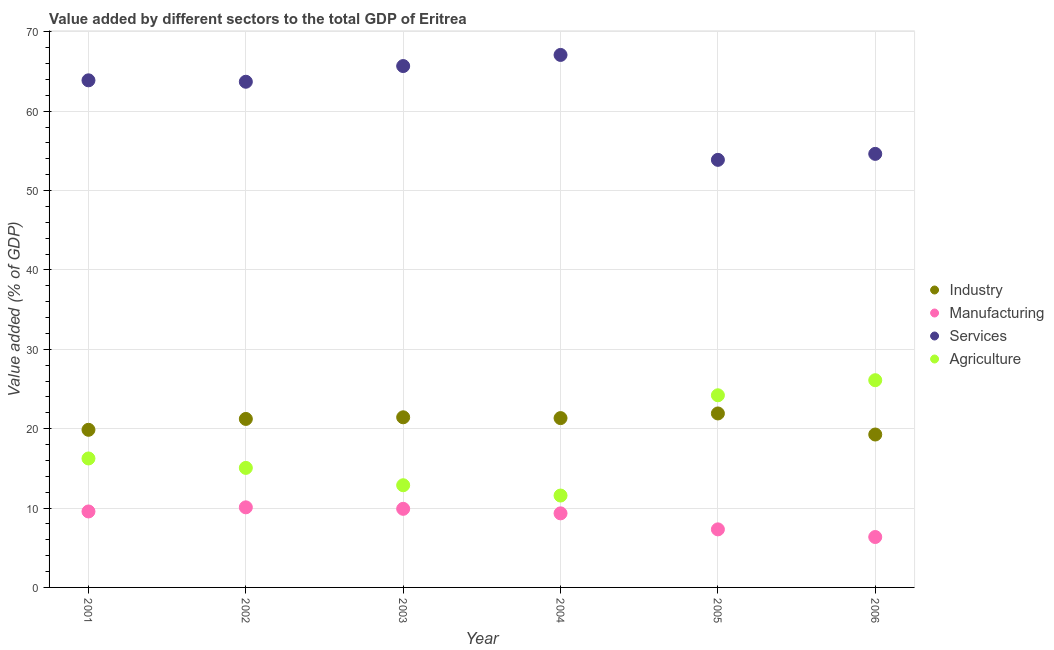How many different coloured dotlines are there?
Give a very brief answer. 4. Is the number of dotlines equal to the number of legend labels?
Ensure brevity in your answer.  Yes. What is the value added by agricultural sector in 2004?
Provide a short and direct response. 11.58. Across all years, what is the maximum value added by manufacturing sector?
Offer a terse response. 10.09. Across all years, what is the minimum value added by industrial sector?
Your answer should be compact. 19.27. In which year was the value added by services sector maximum?
Make the answer very short. 2004. In which year was the value added by manufacturing sector minimum?
Your response must be concise. 2006. What is the total value added by manufacturing sector in the graph?
Offer a terse response. 52.56. What is the difference between the value added by manufacturing sector in 2001 and that in 2002?
Your response must be concise. -0.52. What is the difference between the value added by industrial sector in 2001 and the value added by manufacturing sector in 2004?
Your response must be concise. 10.53. What is the average value added by services sector per year?
Your response must be concise. 61.48. In the year 2005, what is the difference between the value added by manufacturing sector and value added by services sector?
Your answer should be compact. -46.56. What is the ratio of the value added by industrial sector in 2003 to that in 2005?
Provide a short and direct response. 0.98. Is the value added by manufacturing sector in 2005 less than that in 2006?
Your answer should be compact. No. Is the difference between the value added by agricultural sector in 2003 and 2004 greater than the difference between the value added by services sector in 2003 and 2004?
Your answer should be compact. Yes. What is the difference between the highest and the second highest value added by manufacturing sector?
Your answer should be compact. 0.19. What is the difference between the highest and the lowest value added by agricultural sector?
Your answer should be very brief. 14.53. In how many years, is the value added by industrial sector greater than the average value added by industrial sector taken over all years?
Your answer should be compact. 4. Is the value added by manufacturing sector strictly greater than the value added by services sector over the years?
Make the answer very short. No. Is the value added by manufacturing sector strictly less than the value added by services sector over the years?
Your response must be concise. Yes. What is the difference between two consecutive major ticks on the Y-axis?
Your answer should be very brief. 10. Are the values on the major ticks of Y-axis written in scientific E-notation?
Give a very brief answer. No. Does the graph contain any zero values?
Give a very brief answer. No. Where does the legend appear in the graph?
Ensure brevity in your answer.  Center right. How many legend labels are there?
Provide a succinct answer. 4. How are the legend labels stacked?
Your answer should be very brief. Vertical. What is the title of the graph?
Your response must be concise. Value added by different sectors to the total GDP of Eritrea. What is the label or title of the Y-axis?
Provide a succinct answer. Value added (% of GDP). What is the Value added (% of GDP) in Industry in 2001?
Give a very brief answer. 19.86. What is the Value added (% of GDP) of Manufacturing in 2001?
Your answer should be compact. 9.57. What is the Value added (% of GDP) in Services in 2001?
Ensure brevity in your answer.  63.89. What is the Value added (% of GDP) of Agriculture in 2001?
Your response must be concise. 16.25. What is the Value added (% of GDP) in Industry in 2002?
Your answer should be very brief. 21.23. What is the Value added (% of GDP) of Manufacturing in 2002?
Your answer should be compact. 10.09. What is the Value added (% of GDP) in Services in 2002?
Keep it short and to the point. 63.71. What is the Value added (% of GDP) in Agriculture in 2002?
Ensure brevity in your answer.  15.06. What is the Value added (% of GDP) of Industry in 2003?
Provide a succinct answer. 21.44. What is the Value added (% of GDP) of Manufacturing in 2003?
Offer a terse response. 9.9. What is the Value added (% of GDP) in Services in 2003?
Keep it short and to the point. 65.69. What is the Value added (% of GDP) of Agriculture in 2003?
Offer a very short reply. 12.87. What is the Value added (% of GDP) of Industry in 2004?
Ensure brevity in your answer.  21.33. What is the Value added (% of GDP) in Manufacturing in 2004?
Offer a very short reply. 9.33. What is the Value added (% of GDP) in Services in 2004?
Your answer should be compact. 67.09. What is the Value added (% of GDP) of Agriculture in 2004?
Ensure brevity in your answer.  11.58. What is the Value added (% of GDP) of Industry in 2005?
Your response must be concise. 21.92. What is the Value added (% of GDP) in Manufacturing in 2005?
Your answer should be very brief. 7.31. What is the Value added (% of GDP) of Services in 2005?
Your answer should be very brief. 53.87. What is the Value added (% of GDP) of Agriculture in 2005?
Offer a very short reply. 24.21. What is the Value added (% of GDP) of Industry in 2006?
Your answer should be very brief. 19.27. What is the Value added (% of GDP) in Manufacturing in 2006?
Make the answer very short. 6.35. What is the Value added (% of GDP) in Services in 2006?
Provide a succinct answer. 54.63. What is the Value added (% of GDP) of Agriculture in 2006?
Your answer should be very brief. 26.11. Across all years, what is the maximum Value added (% of GDP) of Industry?
Keep it short and to the point. 21.92. Across all years, what is the maximum Value added (% of GDP) in Manufacturing?
Your answer should be compact. 10.09. Across all years, what is the maximum Value added (% of GDP) of Services?
Keep it short and to the point. 67.09. Across all years, what is the maximum Value added (% of GDP) of Agriculture?
Your response must be concise. 26.11. Across all years, what is the minimum Value added (% of GDP) of Industry?
Your response must be concise. 19.27. Across all years, what is the minimum Value added (% of GDP) in Manufacturing?
Your answer should be compact. 6.35. Across all years, what is the minimum Value added (% of GDP) of Services?
Make the answer very short. 53.87. Across all years, what is the minimum Value added (% of GDP) in Agriculture?
Provide a short and direct response. 11.58. What is the total Value added (% of GDP) in Industry in the graph?
Provide a short and direct response. 125.04. What is the total Value added (% of GDP) of Manufacturing in the graph?
Offer a very short reply. 52.56. What is the total Value added (% of GDP) in Services in the graph?
Provide a short and direct response. 368.88. What is the total Value added (% of GDP) in Agriculture in the graph?
Provide a succinct answer. 106.08. What is the difference between the Value added (% of GDP) in Industry in 2001 and that in 2002?
Offer a very short reply. -1.37. What is the difference between the Value added (% of GDP) of Manufacturing in 2001 and that in 2002?
Offer a very short reply. -0.52. What is the difference between the Value added (% of GDP) in Services in 2001 and that in 2002?
Provide a succinct answer. 0.18. What is the difference between the Value added (% of GDP) in Agriculture in 2001 and that in 2002?
Provide a succinct answer. 1.19. What is the difference between the Value added (% of GDP) in Industry in 2001 and that in 2003?
Provide a succinct answer. -1.58. What is the difference between the Value added (% of GDP) of Manufacturing in 2001 and that in 2003?
Offer a terse response. -0.33. What is the difference between the Value added (% of GDP) of Services in 2001 and that in 2003?
Your answer should be very brief. -1.8. What is the difference between the Value added (% of GDP) in Agriculture in 2001 and that in 2003?
Ensure brevity in your answer.  3.37. What is the difference between the Value added (% of GDP) of Industry in 2001 and that in 2004?
Provide a succinct answer. -1.47. What is the difference between the Value added (% of GDP) in Manufacturing in 2001 and that in 2004?
Your answer should be compact. 0.24. What is the difference between the Value added (% of GDP) in Services in 2001 and that in 2004?
Provide a succinct answer. -3.2. What is the difference between the Value added (% of GDP) in Agriculture in 2001 and that in 2004?
Make the answer very short. 4.67. What is the difference between the Value added (% of GDP) in Industry in 2001 and that in 2005?
Your answer should be very brief. -2.06. What is the difference between the Value added (% of GDP) in Manufacturing in 2001 and that in 2005?
Make the answer very short. 2.26. What is the difference between the Value added (% of GDP) of Services in 2001 and that in 2005?
Your answer should be very brief. 10.02. What is the difference between the Value added (% of GDP) of Agriculture in 2001 and that in 2005?
Provide a short and direct response. -7.96. What is the difference between the Value added (% of GDP) of Industry in 2001 and that in 2006?
Your answer should be very brief. 0.59. What is the difference between the Value added (% of GDP) of Manufacturing in 2001 and that in 2006?
Make the answer very short. 3.22. What is the difference between the Value added (% of GDP) of Services in 2001 and that in 2006?
Provide a succinct answer. 9.27. What is the difference between the Value added (% of GDP) in Agriculture in 2001 and that in 2006?
Provide a succinct answer. -9.86. What is the difference between the Value added (% of GDP) in Industry in 2002 and that in 2003?
Offer a terse response. -0.21. What is the difference between the Value added (% of GDP) in Manufacturing in 2002 and that in 2003?
Your answer should be compact. 0.19. What is the difference between the Value added (% of GDP) of Services in 2002 and that in 2003?
Make the answer very short. -1.98. What is the difference between the Value added (% of GDP) of Agriculture in 2002 and that in 2003?
Your response must be concise. 2.19. What is the difference between the Value added (% of GDP) of Industry in 2002 and that in 2004?
Provide a short and direct response. -0.1. What is the difference between the Value added (% of GDP) of Manufacturing in 2002 and that in 2004?
Give a very brief answer. 0.76. What is the difference between the Value added (% of GDP) in Services in 2002 and that in 2004?
Provide a short and direct response. -3.38. What is the difference between the Value added (% of GDP) in Agriculture in 2002 and that in 2004?
Your answer should be very brief. 3.48. What is the difference between the Value added (% of GDP) of Industry in 2002 and that in 2005?
Offer a very short reply. -0.69. What is the difference between the Value added (% of GDP) of Manufacturing in 2002 and that in 2005?
Provide a short and direct response. 2.78. What is the difference between the Value added (% of GDP) of Services in 2002 and that in 2005?
Your answer should be compact. 9.84. What is the difference between the Value added (% of GDP) in Agriculture in 2002 and that in 2005?
Give a very brief answer. -9.15. What is the difference between the Value added (% of GDP) in Industry in 2002 and that in 2006?
Provide a succinct answer. 1.96. What is the difference between the Value added (% of GDP) of Manufacturing in 2002 and that in 2006?
Your answer should be very brief. 3.74. What is the difference between the Value added (% of GDP) in Services in 2002 and that in 2006?
Your answer should be compact. 9.09. What is the difference between the Value added (% of GDP) in Agriculture in 2002 and that in 2006?
Keep it short and to the point. -11.05. What is the difference between the Value added (% of GDP) of Industry in 2003 and that in 2004?
Keep it short and to the point. 0.1. What is the difference between the Value added (% of GDP) in Manufacturing in 2003 and that in 2004?
Your answer should be compact. 0.57. What is the difference between the Value added (% of GDP) in Services in 2003 and that in 2004?
Keep it short and to the point. -1.4. What is the difference between the Value added (% of GDP) in Agriculture in 2003 and that in 2004?
Provide a short and direct response. 1.3. What is the difference between the Value added (% of GDP) of Industry in 2003 and that in 2005?
Make the answer very short. -0.48. What is the difference between the Value added (% of GDP) in Manufacturing in 2003 and that in 2005?
Your answer should be compact. 2.59. What is the difference between the Value added (% of GDP) of Services in 2003 and that in 2005?
Make the answer very short. 11.82. What is the difference between the Value added (% of GDP) of Agriculture in 2003 and that in 2005?
Offer a very short reply. -11.33. What is the difference between the Value added (% of GDP) of Industry in 2003 and that in 2006?
Offer a very short reply. 2.17. What is the difference between the Value added (% of GDP) of Manufacturing in 2003 and that in 2006?
Offer a terse response. 3.55. What is the difference between the Value added (% of GDP) in Services in 2003 and that in 2006?
Your response must be concise. 11.06. What is the difference between the Value added (% of GDP) in Agriculture in 2003 and that in 2006?
Offer a terse response. -13.23. What is the difference between the Value added (% of GDP) of Industry in 2004 and that in 2005?
Your answer should be very brief. -0.59. What is the difference between the Value added (% of GDP) of Manufacturing in 2004 and that in 2005?
Ensure brevity in your answer.  2.02. What is the difference between the Value added (% of GDP) in Services in 2004 and that in 2005?
Offer a very short reply. 13.22. What is the difference between the Value added (% of GDP) of Agriculture in 2004 and that in 2005?
Your answer should be very brief. -12.63. What is the difference between the Value added (% of GDP) in Industry in 2004 and that in 2006?
Offer a terse response. 2.07. What is the difference between the Value added (% of GDP) in Manufacturing in 2004 and that in 2006?
Your answer should be very brief. 2.98. What is the difference between the Value added (% of GDP) in Services in 2004 and that in 2006?
Your response must be concise. 12.47. What is the difference between the Value added (% of GDP) of Agriculture in 2004 and that in 2006?
Your answer should be very brief. -14.53. What is the difference between the Value added (% of GDP) of Industry in 2005 and that in 2006?
Offer a terse response. 2.65. What is the difference between the Value added (% of GDP) in Manufacturing in 2005 and that in 2006?
Provide a short and direct response. 0.96. What is the difference between the Value added (% of GDP) in Services in 2005 and that in 2006?
Ensure brevity in your answer.  -0.75. What is the difference between the Value added (% of GDP) of Agriculture in 2005 and that in 2006?
Ensure brevity in your answer.  -1.9. What is the difference between the Value added (% of GDP) in Industry in 2001 and the Value added (% of GDP) in Manufacturing in 2002?
Give a very brief answer. 9.77. What is the difference between the Value added (% of GDP) of Industry in 2001 and the Value added (% of GDP) of Services in 2002?
Your response must be concise. -43.85. What is the difference between the Value added (% of GDP) of Industry in 2001 and the Value added (% of GDP) of Agriculture in 2002?
Offer a terse response. 4.8. What is the difference between the Value added (% of GDP) in Manufacturing in 2001 and the Value added (% of GDP) in Services in 2002?
Give a very brief answer. -54.14. What is the difference between the Value added (% of GDP) in Manufacturing in 2001 and the Value added (% of GDP) in Agriculture in 2002?
Your answer should be compact. -5.49. What is the difference between the Value added (% of GDP) of Services in 2001 and the Value added (% of GDP) of Agriculture in 2002?
Your answer should be compact. 48.83. What is the difference between the Value added (% of GDP) of Industry in 2001 and the Value added (% of GDP) of Manufacturing in 2003?
Ensure brevity in your answer.  9.96. What is the difference between the Value added (% of GDP) of Industry in 2001 and the Value added (% of GDP) of Services in 2003?
Your response must be concise. -45.83. What is the difference between the Value added (% of GDP) in Industry in 2001 and the Value added (% of GDP) in Agriculture in 2003?
Offer a very short reply. 6.98. What is the difference between the Value added (% of GDP) in Manufacturing in 2001 and the Value added (% of GDP) in Services in 2003?
Provide a succinct answer. -56.12. What is the difference between the Value added (% of GDP) in Manufacturing in 2001 and the Value added (% of GDP) in Agriculture in 2003?
Keep it short and to the point. -3.3. What is the difference between the Value added (% of GDP) in Services in 2001 and the Value added (% of GDP) in Agriculture in 2003?
Offer a very short reply. 51.02. What is the difference between the Value added (% of GDP) in Industry in 2001 and the Value added (% of GDP) in Manufacturing in 2004?
Your answer should be compact. 10.53. What is the difference between the Value added (% of GDP) of Industry in 2001 and the Value added (% of GDP) of Services in 2004?
Provide a succinct answer. -47.23. What is the difference between the Value added (% of GDP) of Industry in 2001 and the Value added (% of GDP) of Agriculture in 2004?
Your answer should be very brief. 8.28. What is the difference between the Value added (% of GDP) in Manufacturing in 2001 and the Value added (% of GDP) in Services in 2004?
Offer a terse response. -57.52. What is the difference between the Value added (% of GDP) in Manufacturing in 2001 and the Value added (% of GDP) in Agriculture in 2004?
Give a very brief answer. -2. What is the difference between the Value added (% of GDP) of Services in 2001 and the Value added (% of GDP) of Agriculture in 2004?
Offer a terse response. 52.32. What is the difference between the Value added (% of GDP) in Industry in 2001 and the Value added (% of GDP) in Manufacturing in 2005?
Keep it short and to the point. 12.55. What is the difference between the Value added (% of GDP) of Industry in 2001 and the Value added (% of GDP) of Services in 2005?
Provide a short and direct response. -34.01. What is the difference between the Value added (% of GDP) in Industry in 2001 and the Value added (% of GDP) in Agriculture in 2005?
Offer a very short reply. -4.35. What is the difference between the Value added (% of GDP) in Manufacturing in 2001 and the Value added (% of GDP) in Services in 2005?
Your response must be concise. -44.3. What is the difference between the Value added (% of GDP) in Manufacturing in 2001 and the Value added (% of GDP) in Agriculture in 2005?
Provide a short and direct response. -14.64. What is the difference between the Value added (% of GDP) of Services in 2001 and the Value added (% of GDP) of Agriculture in 2005?
Keep it short and to the point. 39.68. What is the difference between the Value added (% of GDP) in Industry in 2001 and the Value added (% of GDP) in Manufacturing in 2006?
Provide a short and direct response. 13.51. What is the difference between the Value added (% of GDP) in Industry in 2001 and the Value added (% of GDP) in Services in 2006?
Offer a very short reply. -34.77. What is the difference between the Value added (% of GDP) in Industry in 2001 and the Value added (% of GDP) in Agriculture in 2006?
Provide a short and direct response. -6.25. What is the difference between the Value added (% of GDP) in Manufacturing in 2001 and the Value added (% of GDP) in Services in 2006?
Provide a short and direct response. -45.05. What is the difference between the Value added (% of GDP) in Manufacturing in 2001 and the Value added (% of GDP) in Agriculture in 2006?
Your answer should be compact. -16.54. What is the difference between the Value added (% of GDP) in Services in 2001 and the Value added (% of GDP) in Agriculture in 2006?
Offer a very short reply. 37.78. What is the difference between the Value added (% of GDP) in Industry in 2002 and the Value added (% of GDP) in Manufacturing in 2003?
Offer a terse response. 11.33. What is the difference between the Value added (% of GDP) in Industry in 2002 and the Value added (% of GDP) in Services in 2003?
Your answer should be compact. -44.46. What is the difference between the Value added (% of GDP) in Industry in 2002 and the Value added (% of GDP) in Agriculture in 2003?
Make the answer very short. 8.35. What is the difference between the Value added (% of GDP) in Manufacturing in 2002 and the Value added (% of GDP) in Services in 2003?
Your answer should be very brief. -55.6. What is the difference between the Value added (% of GDP) in Manufacturing in 2002 and the Value added (% of GDP) in Agriculture in 2003?
Provide a succinct answer. -2.78. What is the difference between the Value added (% of GDP) of Services in 2002 and the Value added (% of GDP) of Agriculture in 2003?
Your response must be concise. 50.84. What is the difference between the Value added (% of GDP) of Industry in 2002 and the Value added (% of GDP) of Manufacturing in 2004?
Keep it short and to the point. 11.9. What is the difference between the Value added (% of GDP) in Industry in 2002 and the Value added (% of GDP) in Services in 2004?
Ensure brevity in your answer.  -45.86. What is the difference between the Value added (% of GDP) in Industry in 2002 and the Value added (% of GDP) in Agriculture in 2004?
Your answer should be compact. 9.65. What is the difference between the Value added (% of GDP) of Manufacturing in 2002 and the Value added (% of GDP) of Services in 2004?
Provide a short and direct response. -57. What is the difference between the Value added (% of GDP) of Manufacturing in 2002 and the Value added (% of GDP) of Agriculture in 2004?
Give a very brief answer. -1.49. What is the difference between the Value added (% of GDP) of Services in 2002 and the Value added (% of GDP) of Agriculture in 2004?
Make the answer very short. 52.14. What is the difference between the Value added (% of GDP) in Industry in 2002 and the Value added (% of GDP) in Manufacturing in 2005?
Make the answer very short. 13.91. What is the difference between the Value added (% of GDP) in Industry in 2002 and the Value added (% of GDP) in Services in 2005?
Your answer should be compact. -32.64. What is the difference between the Value added (% of GDP) in Industry in 2002 and the Value added (% of GDP) in Agriculture in 2005?
Keep it short and to the point. -2.98. What is the difference between the Value added (% of GDP) in Manufacturing in 2002 and the Value added (% of GDP) in Services in 2005?
Your answer should be very brief. -43.78. What is the difference between the Value added (% of GDP) of Manufacturing in 2002 and the Value added (% of GDP) of Agriculture in 2005?
Your answer should be compact. -14.12. What is the difference between the Value added (% of GDP) in Services in 2002 and the Value added (% of GDP) in Agriculture in 2005?
Offer a very short reply. 39.5. What is the difference between the Value added (% of GDP) in Industry in 2002 and the Value added (% of GDP) in Manufacturing in 2006?
Offer a terse response. 14.88. What is the difference between the Value added (% of GDP) in Industry in 2002 and the Value added (% of GDP) in Services in 2006?
Give a very brief answer. -33.4. What is the difference between the Value added (% of GDP) of Industry in 2002 and the Value added (% of GDP) of Agriculture in 2006?
Make the answer very short. -4.88. What is the difference between the Value added (% of GDP) of Manufacturing in 2002 and the Value added (% of GDP) of Services in 2006?
Your response must be concise. -44.53. What is the difference between the Value added (% of GDP) of Manufacturing in 2002 and the Value added (% of GDP) of Agriculture in 2006?
Your response must be concise. -16.02. What is the difference between the Value added (% of GDP) in Services in 2002 and the Value added (% of GDP) in Agriculture in 2006?
Provide a succinct answer. 37.6. What is the difference between the Value added (% of GDP) of Industry in 2003 and the Value added (% of GDP) of Manufacturing in 2004?
Give a very brief answer. 12.1. What is the difference between the Value added (% of GDP) in Industry in 2003 and the Value added (% of GDP) in Services in 2004?
Offer a very short reply. -45.66. What is the difference between the Value added (% of GDP) of Industry in 2003 and the Value added (% of GDP) of Agriculture in 2004?
Your answer should be very brief. 9.86. What is the difference between the Value added (% of GDP) in Manufacturing in 2003 and the Value added (% of GDP) in Services in 2004?
Provide a succinct answer. -57.19. What is the difference between the Value added (% of GDP) of Manufacturing in 2003 and the Value added (% of GDP) of Agriculture in 2004?
Keep it short and to the point. -1.67. What is the difference between the Value added (% of GDP) in Services in 2003 and the Value added (% of GDP) in Agriculture in 2004?
Give a very brief answer. 54.11. What is the difference between the Value added (% of GDP) in Industry in 2003 and the Value added (% of GDP) in Manufacturing in 2005?
Ensure brevity in your answer.  14.12. What is the difference between the Value added (% of GDP) of Industry in 2003 and the Value added (% of GDP) of Services in 2005?
Your answer should be very brief. -32.44. What is the difference between the Value added (% of GDP) in Industry in 2003 and the Value added (% of GDP) in Agriculture in 2005?
Your response must be concise. -2.77. What is the difference between the Value added (% of GDP) in Manufacturing in 2003 and the Value added (% of GDP) in Services in 2005?
Provide a succinct answer. -43.97. What is the difference between the Value added (% of GDP) in Manufacturing in 2003 and the Value added (% of GDP) in Agriculture in 2005?
Provide a short and direct response. -14.31. What is the difference between the Value added (% of GDP) in Services in 2003 and the Value added (% of GDP) in Agriculture in 2005?
Provide a succinct answer. 41.48. What is the difference between the Value added (% of GDP) of Industry in 2003 and the Value added (% of GDP) of Manufacturing in 2006?
Ensure brevity in your answer.  15.08. What is the difference between the Value added (% of GDP) in Industry in 2003 and the Value added (% of GDP) in Services in 2006?
Your response must be concise. -33.19. What is the difference between the Value added (% of GDP) in Industry in 2003 and the Value added (% of GDP) in Agriculture in 2006?
Your response must be concise. -4.67. What is the difference between the Value added (% of GDP) of Manufacturing in 2003 and the Value added (% of GDP) of Services in 2006?
Your response must be concise. -44.72. What is the difference between the Value added (% of GDP) in Manufacturing in 2003 and the Value added (% of GDP) in Agriculture in 2006?
Offer a very short reply. -16.21. What is the difference between the Value added (% of GDP) of Services in 2003 and the Value added (% of GDP) of Agriculture in 2006?
Your answer should be compact. 39.58. What is the difference between the Value added (% of GDP) of Industry in 2004 and the Value added (% of GDP) of Manufacturing in 2005?
Offer a very short reply. 14.02. What is the difference between the Value added (% of GDP) of Industry in 2004 and the Value added (% of GDP) of Services in 2005?
Make the answer very short. -32.54. What is the difference between the Value added (% of GDP) of Industry in 2004 and the Value added (% of GDP) of Agriculture in 2005?
Your answer should be compact. -2.88. What is the difference between the Value added (% of GDP) in Manufacturing in 2004 and the Value added (% of GDP) in Services in 2005?
Ensure brevity in your answer.  -44.54. What is the difference between the Value added (% of GDP) of Manufacturing in 2004 and the Value added (% of GDP) of Agriculture in 2005?
Make the answer very short. -14.88. What is the difference between the Value added (% of GDP) in Services in 2004 and the Value added (% of GDP) in Agriculture in 2005?
Offer a very short reply. 42.88. What is the difference between the Value added (% of GDP) in Industry in 2004 and the Value added (% of GDP) in Manufacturing in 2006?
Your answer should be compact. 14.98. What is the difference between the Value added (% of GDP) of Industry in 2004 and the Value added (% of GDP) of Services in 2006?
Your answer should be very brief. -33.29. What is the difference between the Value added (% of GDP) of Industry in 2004 and the Value added (% of GDP) of Agriculture in 2006?
Ensure brevity in your answer.  -4.78. What is the difference between the Value added (% of GDP) of Manufacturing in 2004 and the Value added (% of GDP) of Services in 2006?
Your answer should be very brief. -45.29. What is the difference between the Value added (% of GDP) of Manufacturing in 2004 and the Value added (% of GDP) of Agriculture in 2006?
Provide a short and direct response. -16.78. What is the difference between the Value added (% of GDP) in Services in 2004 and the Value added (% of GDP) in Agriculture in 2006?
Provide a succinct answer. 40.98. What is the difference between the Value added (% of GDP) of Industry in 2005 and the Value added (% of GDP) of Manufacturing in 2006?
Offer a terse response. 15.57. What is the difference between the Value added (% of GDP) of Industry in 2005 and the Value added (% of GDP) of Services in 2006?
Give a very brief answer. -32.71. What is the difference between the Value added (% of GDP) of Industry in 2005 and the Value added (% of GDP) of Agriculture in 2006?
Your answer should be compact. -4.19. What is the difference between the Value added (% of GDP) of Manufacturing in 2005 and the Value added (% of GDP) of Services in 2006?
Your answer should be compact. -47.31. What is the difference between the Value added (% of GDP) of Manufacturing in 2005 and the Value added (% of GDP) of Agriculture in 2006?
Make the answer very short. -18.79. What is the difference between the Value added (% of GDP) in Services in 2005 and the Value added (% of GDP) in Agriculture in 2006?
Your response must be concise. 27.76. What is the average Value added (% of GDP) of Industry per year?
Offer a terse response. 20.84. What is the average Value added (% of GDP) of Manufacturing per year?
Keep it short and to the point. 8.76. What is the average Value added (% of GDP) of Services per year?
Offer a terse response. 61.48. What is the average Value added (% of GDP) of Agriculture per year?
Offer a very short reply. 17.68. In the year 2001, what is the difference between the Value added (% of GDP) of Industry and Value added (% of GDP) of Manufacturing?
Provide a short and direct response. 10.29. In the year 2001, what is the difference between the Value added (% of GDP) of Industry and Value added (% of GDP) of Services?
Your answer should be compact. -44.03. In the year 2001, what is the difference between the Value added (% of GDP) of Industry and Value added (% of GDP) of Agriculture?
Make the answer very short. 3.61. In the year 2001, what is the difference between the Value added (% of GDP) of Manufacturing and Value added (% of GDP) of Services?
Your answer should be compact. -54.32. In the year 2001, what is the difference between the Value added (% of GDP) in Manufacturing and Value added (% of GDP) in Agriculture?
Your answer should be very brief. -6.68. In the year 2001, what is the difference between the Value added (% of GDP) of Services and Value added (% of GDP) of Agriculture?
Make the answer very short. 47.64. In the year 2002, what is the difference between the Value added (% of GDP) of Industry and Value added (% of GDP) of Manufacturing?
Your answer should be compact. 11.14. In the year 2002, what is the difference between the Value added (% of GDP) in Industry and Value added (% of GDP) in Services?
Keep it short and to the point. -42.48. In the year 2002, what is the difference between the Value added (% of GDP) of Industry and Value added (% of GDP) of Agriculture?
Provide a short and direct response. 6.17. In the year 2002, what is the difference between the Value added (% of GDP) in Manufacturing and Value added (% of GDP) in Services?
Give a very brief answer. -53.62. In the year 2002, what is the difference between the Value added (% of GDP) in Manufacturing and Value added (% of GDP) in Agriculture?
Give a very brief answer. -4.97. In the year 2002, what is the difference between the Value added (% of GDP) in Services and Value added (% of GDP) in Agriculture?
Provide a succinct answer. 48.65. In the year 2003, what is the difference between the Value added (% of GDP) of Industry and Value added (% of GDP) of Manufacturing?
Provide a short and direct response. 11.53. In the year 2003, what is the difference between the Value added (% of GDP) in Industry and Value added (% of GDP) in Services?
Give a very brief answer. -44.25. In the year 2003, what is the difference between the Value added (% of GDP) in Industry and Value added (% of GDP) in Agriculture?
Make the answer very short. 8.56. In the year 2003, what is the difference between the Value added (% of GDP) in Manufacturing and Value added (% of GDP) in Services?
Ensure brevity in your answer.  -55.79. In the year 2003, what is the difference between the Value added (% of GDP) of Manufacturing and Value added (% of GDP) of Agriculture?
Ensure brevity in your answer.  -2.97. In the year 2003, what is the difference between the Value added (% of GDP) in Services and Value added (% of GDP) in Agriculture?
Offer a very short reply. 52.82. In the year 2004, what is the difference between the Value added (% of GDP) in Industry and Value added (% of GDP) in Manufacturing?
Give a very brief answer. 12. In the year 2004, what is the difference between the Value added (% of GDP) in Industry and Value added (% of GDP) in Services?
Offer a terse response. -45.76. In the year 2004, what is the difference between the Value added (% of GDP) of Industry and Value added (% of GDP) of Agriculture?
Offer a very short reply. 9.76. In the year 2004, what is the difference between the Value added (% of GDP) in Manufacturing and Value added (% of GDP) in Services?
Make the answer very short. -57.76. In the year 2004, what is the difference between the Value added (% of GDP) of Manufacturing and Value added (% of GDP) of Agriculture?
Your answer should be very brief. -2.24. In the year 2004, what is the difference between the Value added (% of GDP) of Services and Value added (% of GDP) of Agriculture?
Keep it short and to the point. 55.52. In the year 2005, what is the difference between the Value added (% of GDP) of Industry and Value added (% of GDP) of Manufacturing?
Keep it short and to the point. 14.61. In the year 2005, what is the difference between the Value added (% of GDP) of Industry and Value added (% of GDP) of Services?
Give a very brief answer. -31.95. In the year 2005, what is the difference between the Value added (% of GDP) of Industry and Value added (% of GDP) of Agriculture?
Provide a succinct answer. -2.29. In the year 2005, what is the difference between the Value added (% of GDP) of Manufacturing and Value added (% of GDP) of Services?
Your answer should be compact. -46.56. In the year 2005, what is the difference between the Value added (% of GDP) in Manufacturing and Value added (% of GDP) in Agriculture?
Offer a terse response. -16.89. In the year 2005, what is the difference between the Value added (% of GDP) of Services and Value added (% of GDP) of Agriculture?
Offer a very short reply. 29.66. In the year 2006, what is the difference between the Value added (% of GDP) of Industry and Value added (% of GDP) of Manufacturing?
Offer a terse response. 12.91. In the year 2006, what is the difference between the Value added (% of GDP) in Industry and Value added (% of GDP) in Services?
Your answer should be very brief. -35.36. In the year 2006, what is the difference between the Value added (% of GDP) of Industry and Value added (% of GDP) of Agriculture?
Give a very brief answer. -6.84. In the year 2006, what is the difference between the Value added (% of GDP) in Manufacturing and Value added (% of GDP) in Services?
Offer a very short reply. -48.27. In the year 2006, what is the difference between the Value added (% of GDP) of Manufacturing and Value added (% of GDP) of Agriculture?
Keep it short and to the point. -19.76. In the year 2006, what is the difference between the Value added (% of GDP) of Services and Value added (% of GDP) of Agriculture?
Keep it short and to the point. 28.52. What is the ratio of the Value added (% of GDP) of Industry in 2001 to that in 2002?
Your response must be concise. 0.94. What is the ratio of the Value added (% of GDP) of Manufacturing in 2001 to that in 2002?
Your answer should be compact. 0.95. What is the ratio of the Value added (% of GDP) in Services in 2001 to that in 2002?
Your answer should be compact. 1. What is the ratio of the Value added (% of GDP) of Agriculture in 2001 to that in 2002?
Ensure brevity in your answer.  1.08. What is the ratio of the Value added (% of GDP) of Industry in 2001 to that in 2003?
Provide a succinct answer. 0.93. What is the ratio of the Value added (% of GDP) of Manufacturing in 2001 to that in 2003?
Your response must be concise. 0.97. What is the ratio of the Value added (% of GDP) in Services in 2001 to that in 2003?
Your answer should be compact. 0.97. What is the ratio of the Value added (% of GDP) of Agriculture in 2001 to that in 2003?
Keep it short and to the point. 1.26. What is the ratio of the Value added (% of GDP) in Industry in 2001 to that in 2004?
Offer a terse response. 0.93. What is the ratio of the Value added (% of GDP) in Manufacturing in 2001 to that in 2004?
Keep it short and to the point. 1.03. What is the ratio of the Value added (% of GDP) in Services in 2001 to that in 2004?
Give a very brief answer. 0.95. What is the ratio of the Value added (% of GDP) of Agriculture in 2001 to that in 2004?
Keep it short and to the point. 1.4. What is the ratio of the Value added (% of GDP) of Industry in 2001 to that in 2005?
Your response must be concise. 0.91. What is the ratio of the Value added (% of GDP) in Manufacturing in 2001 to that in 2005?
Your answer should be very brief. 1.31. What is the ratio of the Value added (% of GDP) of Services in 2001 to that in 2005?
Ensure brevity in your answer.  1.19. What is the ratio of the Value added (% of GDP) of Agriculture in 2001 to that in 2005?
Offer a very short reply. 0.67. What is the ratio of the Value added (% of GDP) in Industry in 2001 to that in 2006?
Offer a terse response. 1.03. What is the ratio of the Value added (% of GDP) of Manufacturing in 2001 to that in 2006?
Keep it short and to the point. 1.51. What is the ratio of the Value added (% of GDP) in Services in 2001 to that in 2006?
Keep it short and to the point. 1.17. What is the ratio of the Value added (% of GDP) of Agriculture in 2001 to that in 2006?
Your answer should be compact. 0.62. What is the ratio of the Value added (% of GDP) of Industry in 2002 to that in 2003?
Keep it short and to the point. 0.99. What is the ratio of the Value added (% of GDP) of Manufacturing in 2002 to that in 2003?
Make the answer very short. 1.02. What is the ratio of the Value added (% of GDP) in Services in 2002 to that in 2003?
Offer a very short reply. 0.97. What is the ratio of the Value added (% of GDP) of Agriculture in 2002 to that in 2003?
Provide a succinct answer. 1.17. What is the ratio of the Value added (% of GDP) of Industry in 2002 to that in 2004?
Give a very brief answer. 1. What is the ratio of the Value added (% of GDP) in Manufacturing in 2002 to that in 2004?
Provide a short and direct response. 1.08. What is the ratio of the Value added (% of GDP) of Services in 2002 to that in 2004?
Keep it short and to the point. 0.95. What is the ratio of the Value added (% of GDP) in Agriculture in 2002 to that in 2004?
Provide a succinct answer. 1.3. What is the ratio of the Value added (% of GDP) of Industry in 2002 to that in 2005?
Ensure brevity in your answer.  0.97. What is the ratio of the Value added (% of GDP) of Manufacturing in 2002 to that in 2005?
Offer a terse response. 1.38. What is the ratio of the Value added (% of GDP) of Services in 2002 to that in 2005?
Provide a short and direct response. 1.18. What is the ratio of the Value added (% of GDP) of Agriculture in 2002 to that in 2005?
Make the answer very short. 0.62. What is the ratio of the Value added (% of GDP) of Industry in 2002 to that in 2006?
Keep it short and to the point. 1.1. What is the ratio of the Value added (% of GDP) in Manufacturing in 2002 to that in 2006?
Ensure brevity in your answer.  1.59. What is the ratio of the Value added (% of GDP) of Services in 2002 to that in 2006?
Your response must be concise. 1.17. What is the ratio of the Value added (% of GDP) of Agriculture in 2002 to that in 2006?
Provide a short and direct response. 0.58. What is the ratio of the Value added (% of GDP) of Manufacturing in 2003 to that in 2004?
Keep it short and to the point. 1.06. What is the ratio of the Value added (% of GDP) of Services in 2003 to that in 2004?
Offer a very short reply. 0.98. What is the ratio of the Value added (% of GDP) in Agriculture in 2003 to that in 2004?
Give a very brief answer. 1.11. What is the ratio of the Value added (% of GDP) of Industry in 2003 to that in 2005?
Provide a succinct answer. 0.98. What is the ratio of the Value added (% of GDP) of Manufacturing in 2003 to that in 2005?
Offer a very short reply. 1.35. What is the ratio of the Value added (% of GDP) in Services in 2003 to that in 2005?
Provide a succinct answer. 1.22. What is the ratio of the Value added (% of GDP) of Agriculture in 2003 to that in 2005?
Provide a succinct answer. 0.53. What is the ratio of the Value added (% of GDP) of Industry in 2003 to that in 2006?
Your answer should be compact. 1.11. What is the ratio of the Value added (% of GDP) of Manufacturing in 2003 to that in 2006?
Your answer should be very brief. 1.56. What is the ratio of the Value added (% of GDP) of Services in 2003 to that in 2006?
Your answer should be compact. 1.2. What is the ratio of the Value added (% of GDP) of Agriculture in 2003 to that in 2006?
Offer a terse response. 0.49. What is the ratio of the Value added (% of GDP) of Industry in 2004 to that in 2005?
Ensure brevity in your answer.  0.97. What is the ratio of the Value added (% of GDP) in Manufacturing in 2004 to that in 2005?
Your answer should be very brief. 1.28. What is the ratio of the Value added (% of GDP) of Services in 2004 to that in 2005?
Ensure brevity in your answer.  1.25. What is the ratio of the Value added (% of GDP) of Agriculture in 2004 to that in 2005?
Provide a short and direct response. 0.48. What is the ratio of the Value added (% of GDP) in Industry in 2004 to that in 2006?
Keep it short and to the point. 1.11. What is the ratio of the Value added (% of GDP) in Manufacturing in 2004 to that in 2006?
Keep it short and to the point. 1.47. What is the ratio of the Value added (% of GDP) in Services in 2004 to that in 2006?
Make the answer very short. 1.23. What is the ratio of the Value added (% of GDP) in Agriculture in 2004 to that in 2006?
Give a very brief answer. 0.44. What is the ratio of the Value added (% of GDP) in Industry in 2005 to that in 2006?
Your answer should be compact. 1.14. What is the ratio of the Value added (% of GDP) of Manufacturing in 2005 to that in 2006?
Offer a very short reply. 1.15. What is the ratio of the Value added (% of GDP) of Services in 2005 to that in 2006?
Make the answer very short. 0.99. What is the ratio of the Value added (% of GDP) of Agriculture in 2005 to that in 2006?
Provide a succinct answer. 0.93. What is the difference between the highest and the second highest Value added (% of GDP) of Industry?
Provide a short and direct response. 0.48. What is the difference between the highest and the second highest Value added (% of GDP) in Manufacturing?
Offer a terse response. 0.19. What is the difference between the highest and the second highest Value added (% of GDP) in Services?
Offer a very short reply. 1.4. What is the difference between the highest and the second highest Value added (% of GDP) of Agriculture?
Provide a succinct answer. 1.9. What is the difference between the highest and the lowest Value added (% of GDP) in Industry?
Provide a succinct answer. 2.65. What is the difference between the highest and the lowest Value added (% of GDP) of Manufacturing?
Provide a short and direct response. 3.74. What is the difference between the highest and the lowest Value added (% of GDP) of Services?
Offer a terse response. 13.22. What is the difference between the highest and the lowest Value added (% of GDP) in Agriculture?
Ensure brevity in your answer.  14.53. 